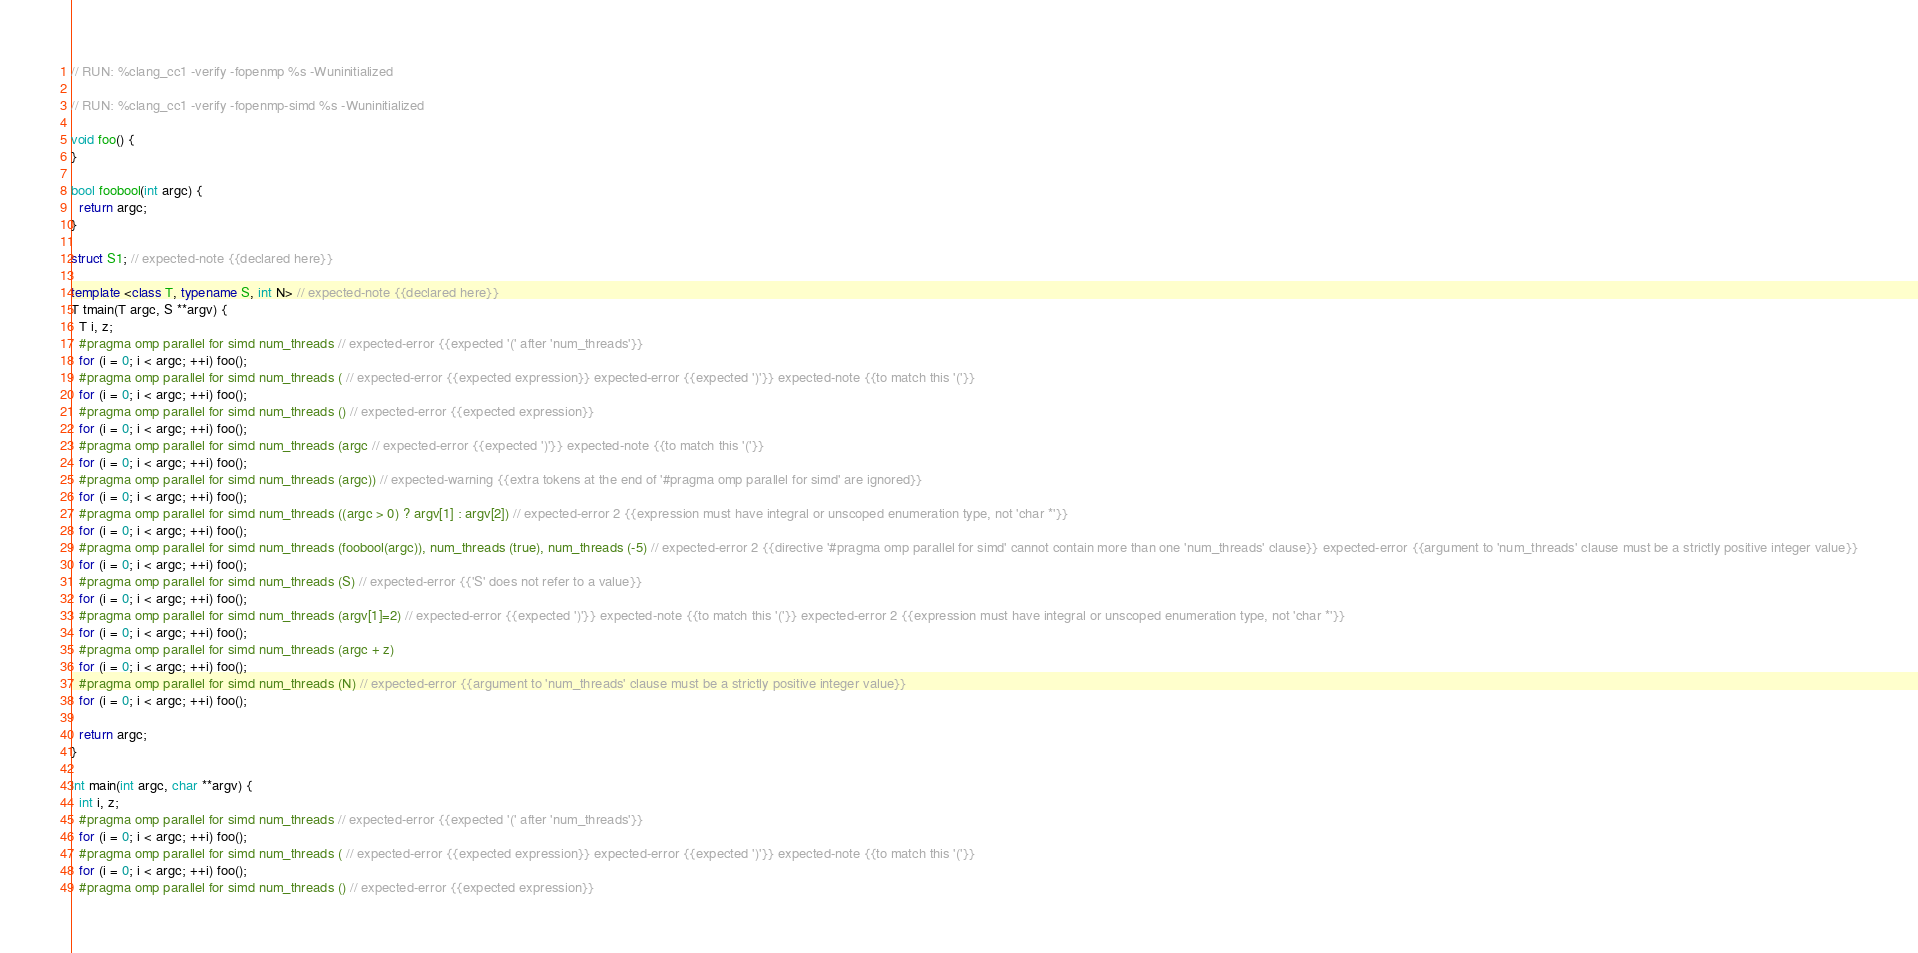<code> <loc_0><loc_0><loc_500><loc_500><_C++_>// RUN: %clang_cc1 -verify -fopenmp %s -Wuninitialized

// RUN: %clang_cc1 -verify -fopenmp-simd %s -Wuninitialized

void foo() {
}

bool foobool(int argc) {
  return argc;
}

struct S1; // expected-note {{declared here}}

template <class T, typename S, int N> // expected-note {{declared here}}
T tmain(T argc, S **argv) {
  T i, z;
  #pragma omp parallel for simd num_threads // expected-error {{expected '(' after 'num_threads'}}
  for (i = 0; i < argc; ++i) foo();
  #pragma omp parallel for simd num_threads ( // expected-error {{expected expression}} expected-error {{expected ')'}} expected-note {{to match this '('}}
  for (i = 0; i < argc; ++i) foo();
  #pragma omp parallel for simd num_threads () // expected-error {{expected expression}}
  for (i = 0; i < argc; ++i) foo();
  #pragma omp parallel for simd num_threads (argc // expected-error {{expected ')'}} expected-note {{to match this '('}}
  for (i = 0; i < argc; ++i) foo();
  #pragma omp parallel for simd num_threads (argc)) // expected-warning {{extra tokens at the end of '#pragma omp parallel for simd' are ignored}}
  for (i = 0; i < argc; ++i) foo();
  #pragma omp parallel for simd num_threads ((argc > 0) ? argv[1] : argv[2]) // expected-error 2 {{expression must have integral or unscoped enumeration type, not 'char *'}}
  for (i = 0; i < argc; ++i) foo();
  #pragma omp parallel for simd num_threads (foobool(argc)), num_threads (true), num_threads (-5) // expected-error 2 {{directive '#pragma omp parallel for simd' cannot contain more than one 'num_threads' clause}} expected-error {{argument to 'num_threads' clause must be a strictly positive integer value}}
  for (i = 0; i < argc; ++i) foo();
  #pragma omp parallel for simd num_threads (S) // expected-error {{'S' does not refer to a value}}
  for (i = 0; i < argc; ++i) foo();
  #pragma omp parallel for simd num_threads (argv[1]=2) // expected-error {{expected ')'}} expected-note {{to match this '('}} expected-error 2 {{expression must have integral or unscoped enumeration type, not 'char *'}}
  for (i = 0; i < argc; ++i) foo();
  #pragma omp parallel for simd num_threads (argc + z)
  for (i = 0; i < argc; ++i) foo();
  #pragma omp parallel for simd num_threads (N) // expected-error {{argument to 'num_threads' clause must be a strictly positive integer value}}
  for (i = 0; i < argc; ++i) foo();

  return argc;
}

int main(int argc, char **argv) {
  int i, z;
  #pragma omp parallel for simd num_threads // expected-error {{expected '(' after 'num_threads'}}
  for (i = 0; i < argc; ++i) foo();
  #pragma omp parallel for simd num_threads ( // expected-error {{expected expression}} expected-error {{expected ')'}} expected-note {{to match this '('}}
  for (i = 0; i < argc; ++i) foo();
  #pragma omp parallel for simd num_threads () // expected-error {{expected expression}}</code> 